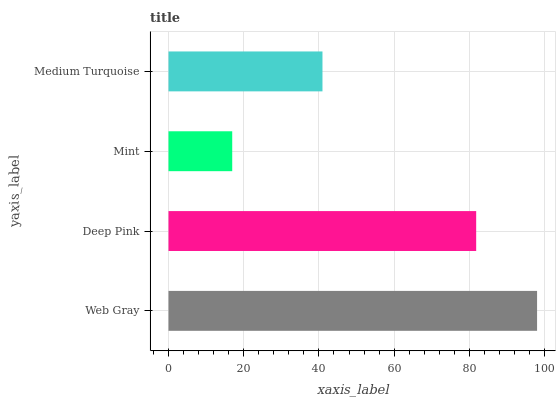Is Mint the minimum?
Answer yes or no. Yes. Is Web Gray the maximum?
Answer yes or no. Yes. Is Deep Pink the minimum?
Answer yes or no. No. Is Deep Pink the maximum?
Answer yes or no. No. Is Web Gray greater than Deep Pink?
Answer yes or no. Yes. Is Deep Pink less than Web Gray?
Answer yes or no. Yes. Is Deep Pink greater than Web Gray?
Answer yes or no. No. Is Web Gray less than Deep Pink?
Answer yes or no. No. Is Deep Pink the high median?
Answer yes or no. Yes. Is Medium Turquoise the low median?
Answer yes or no. Yes. Is Web Gray the high median?
Answer yes or no. No. Is Deep Pink the low median?
Answer yes or no. No. 